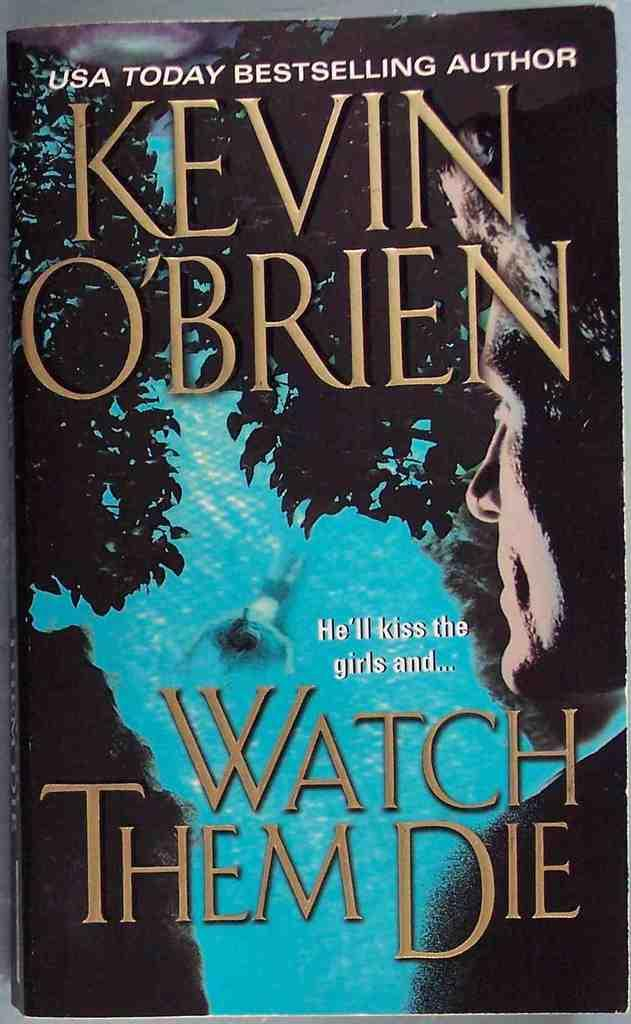Provide a one-sentence caption for the provided image. the cover of book Watch them Die by Kevin O'Brien. 